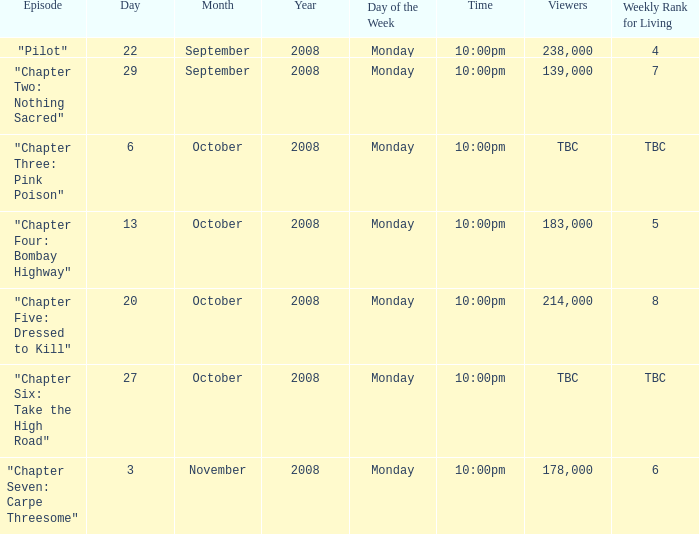What is the episode with the 183,000 viewers? "Chapter Four: Bombay Highway". 